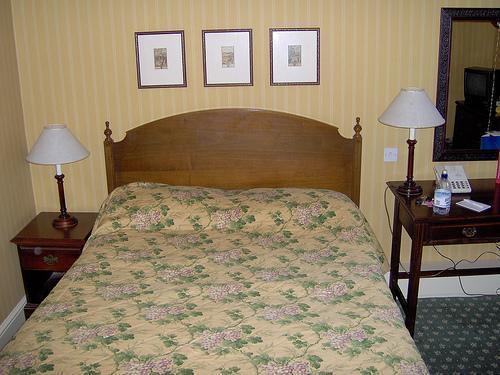How many framed pictures?
Give a very brief answer. 3. How many mirrors?
Give a very brief answer. 1. How many bottles of water?
Give a very brief answer. 1. How many lamps?
Give a very brief answer. 2. How many lamps are to the right of the bed?
Give a very brief answer. 1. 